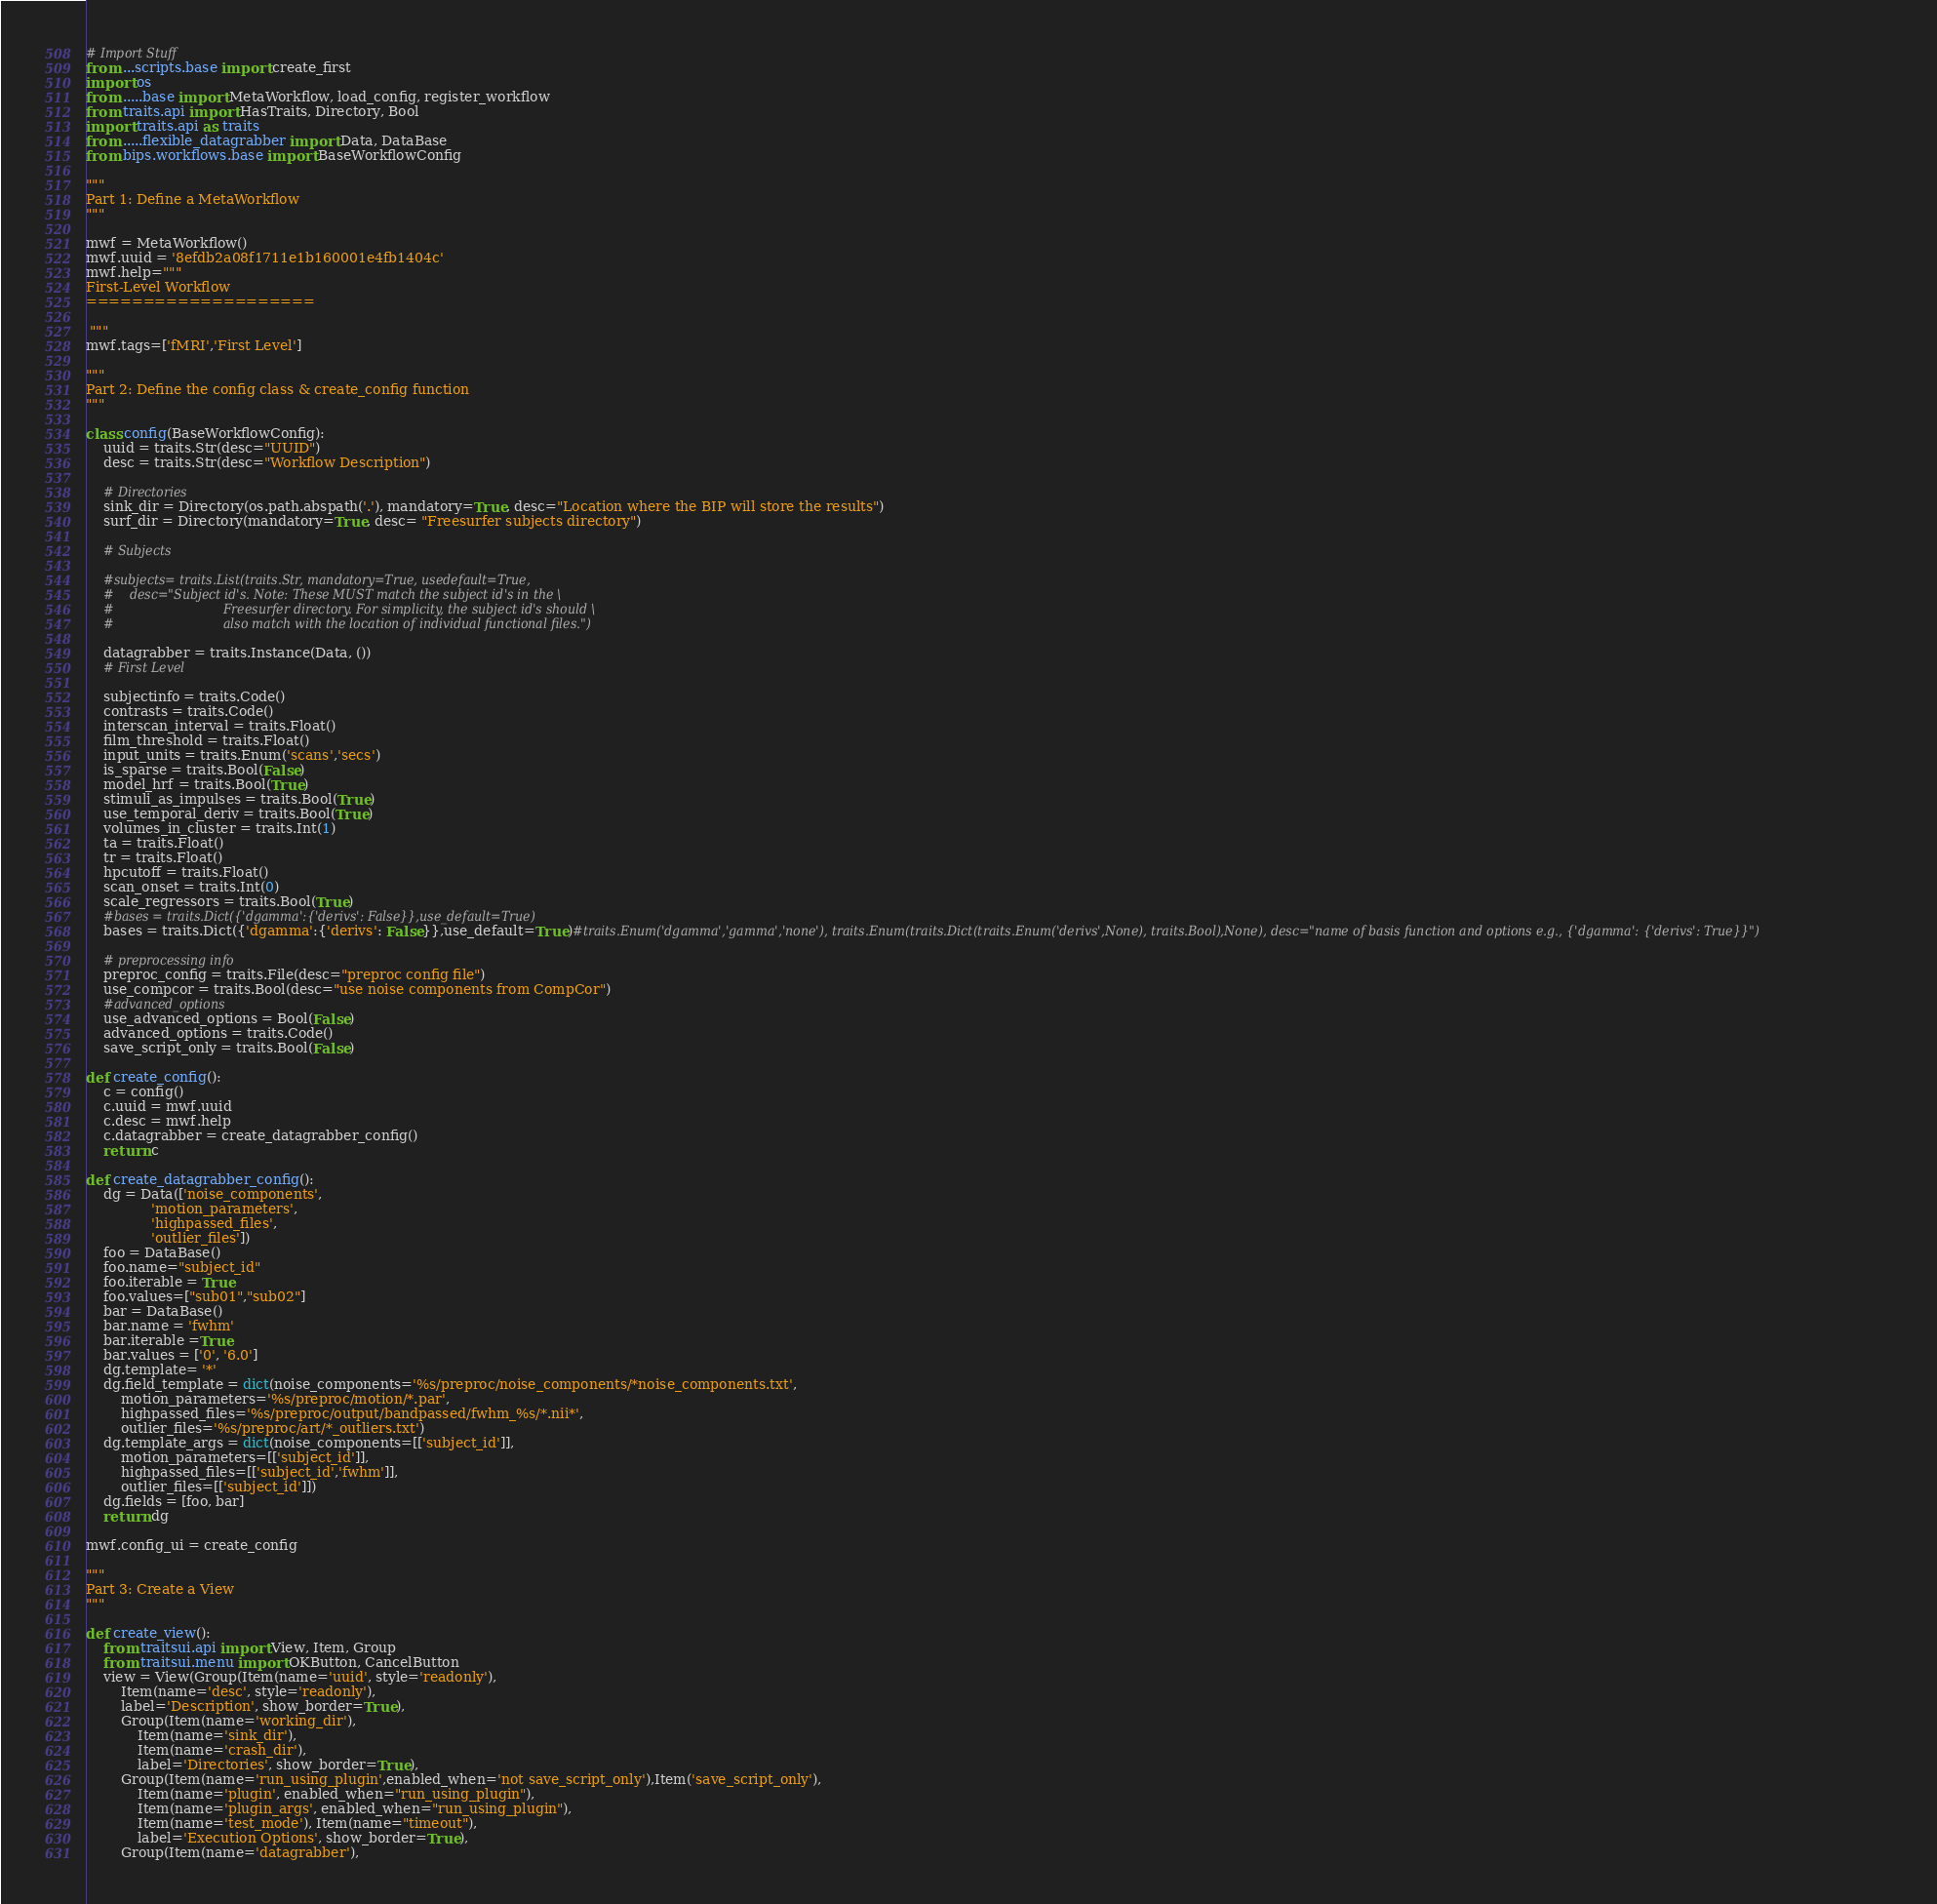<code> <loc_0><loc_0><loc_500><loc_500><_Python_># Import Stuff
from ...scripts.base import create_first
import os
from .....base import MetaWorkflow, load_config, register_workflow
from traits.api import HasTraits, Directory, Bool
import traits.api as traits
from .....flexible_datagrabber import Data, DataBase
from bips.workflows.base import BaseWorkflowConfig

"""
Part 1: Define a MetaWorkflow
"""

mwf = MetaWorkflow()
mwf.uuid = '8efdb2a08f1711e1b160001e4fb1404c'
mwf.help="""
First-Level Workflow
====================

 """
mwf.tags=['fMRI','First Level']

"""
Part 2: Define the config class & create_config function
"""

class config(BaseWorkflowConfig):
    uuid = traits.Str(desc="UUID")
    desc = traits.Str(desc="Workflow Description")
    
    # Directories
    sink_dir = Directory(os.path.abspath('.'), mandatory=True, desc="Location where the BIP will store the results")
    surf_dir = Directory(mandatory=True, desc= "Freesurfer subjects directory")

    # Subjects

    #subjects= traits.List(traits.Str, mandatory=True, usedefault=True,
    #    desc="Subject id's. Note: These MUST match the subject id's in the \
    #                            Freesurfer directory. For simplicity, the subject id's should \
    #                            also match with the location of individual functional files.")

    datagrabber = traits.Instance(Data, ())
    # First Level

    subjectinfo = traits.Code()
    contrasts = traits.Code()
    interscan_interval = traits.Float()
    film_threshold = traits.Float()
    input_units = traits.Enum('scans','secs')
    is_sparse = traits.Bool(False)
    model_hrf = traits.Bool(True)
    stimuli_as_impulses = traits.Bool(True)
    use_temporal_deriv = traits.Bool(True)
    volumes_in_cluster = traits.Int(1)
    ta = traits.Float()
    tr = traits.Float()
    hpcutoff = traits.Float()
    scan_onset = traits.Int(0)
    scale_regressors = traits.Bool(True)
    #bases = traits.Dict({'dgamma':{'derivs': False}},use_default=True)
    bases = traits.Dict({'dgamma':{'derivs': False}},use_default=True)#traits.Enum('dgamma','gamma','none'), traits.Enum(traits.Dict(traits.Enum('derivs',None), traits.Bool),None), desc="name of basis function and options e.g., {'dgamma': {'derivs': True}}")

    # preprocessing info
    preproc_config = traits.File(desc="preproc config file")
    use_compcor = traits.Bool(desc="use noise components from CompCor")
    #advanced_options
    use_advanced_options = Bool(False)
    advanced_options = traits.Code()
    save_script_only = traits.Bool(False)

def create_config():
    c = config()
    c.uuid = mwf.uuid
    c.desc = mwf.help
    c.datagrabber = create_datagrabber_config()
    return c

def create_datagrabber_config():
    dg = Data(['noise_components',
               'motion_parameters',
               'highpassed_files',
               'outlier_files'])
    foo = DataBase()
    foo.name="subject_id"
    foo.iterable = True
    foo.values=["sub01","sub02"]
    bar = DataBase()
    bar.name = 'fwhm'
    bar.iterable =True
    bar.values = ['0', '6.0']
    dg.template= '*'
    dg.field_template = dict(noise_components='%s/preproc/noise_components/*noise_components.txt',
        motion_parameters='%s/preproc/motion/*.par',
        highpassed_files='%s/preproc/output/bandpassed/fwhm_%s/*.nii*',
        outlier_files='%s/preproc/art/*_outliers.txt')
    dg.template_args = dict(noise_components=[['subject_id']],
        motion_parameters=[['subject_id']],
        highpassed_files=[['subject_id','fwhm']],
        outlier_files=[['subject_id']])
    dg.fields = [foo, bar]
    return dg

mwf.config_ui = create_config

"""
Part 3: Create a View
"""

def create_view():
    from traitsui.api import View, Item, Group
    from traitsui.menu import OKButton, CancelButton
    view = View(Group(Item(name='uuid', style='readonly'),
        Item(name='desc', style='readonly'),
        label='Description', show_border=True),
        Group(Item(name='working_dir'),
            Item(name='sink_dir'),
            Item(name='crash_dir'),
            label='Directories', show_border=True),
        Group(Item(name='run_using_plugin',enabled_when='not save_script_only'),Item('save_script_only'),
            Item(name='plugin', enabled_when="run_using_plugin"),
            Item(name='plugin_args', enabled_when="run_using_plugin"),
            Item(name='test_mode'), Item(name="timeout"),
            label='Execution Options', show_border=True),
        Group(Item(name='datagrabber'),</code> 